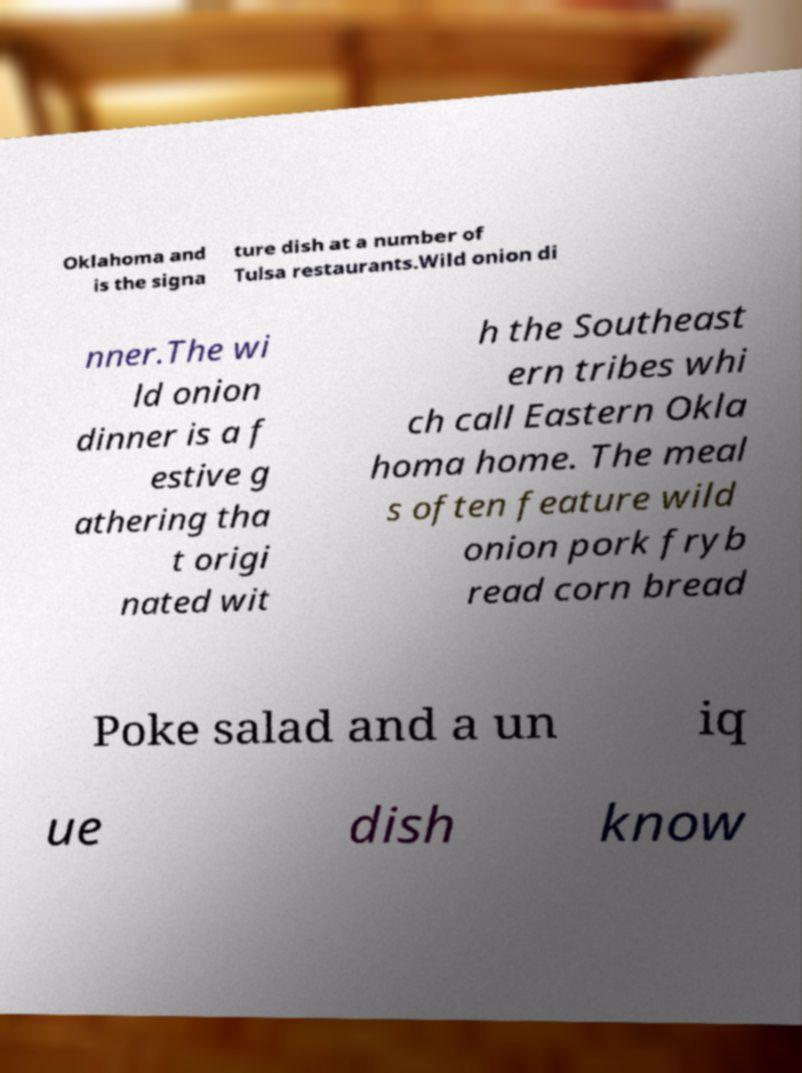Please identify and transcribe the text found in this image. Oklahoma and is the signa ture dish at a number of Tulsa restaurants.Wild onion di nner.The wi ld onion dinner is a f estive g athering tha t origi nated wit h the Southeast ern tribes whi ch call Eastern Okla homa home. The meal s often feature wild onion pork fryb read corn bread Poke salad and a un iq ue dish know 